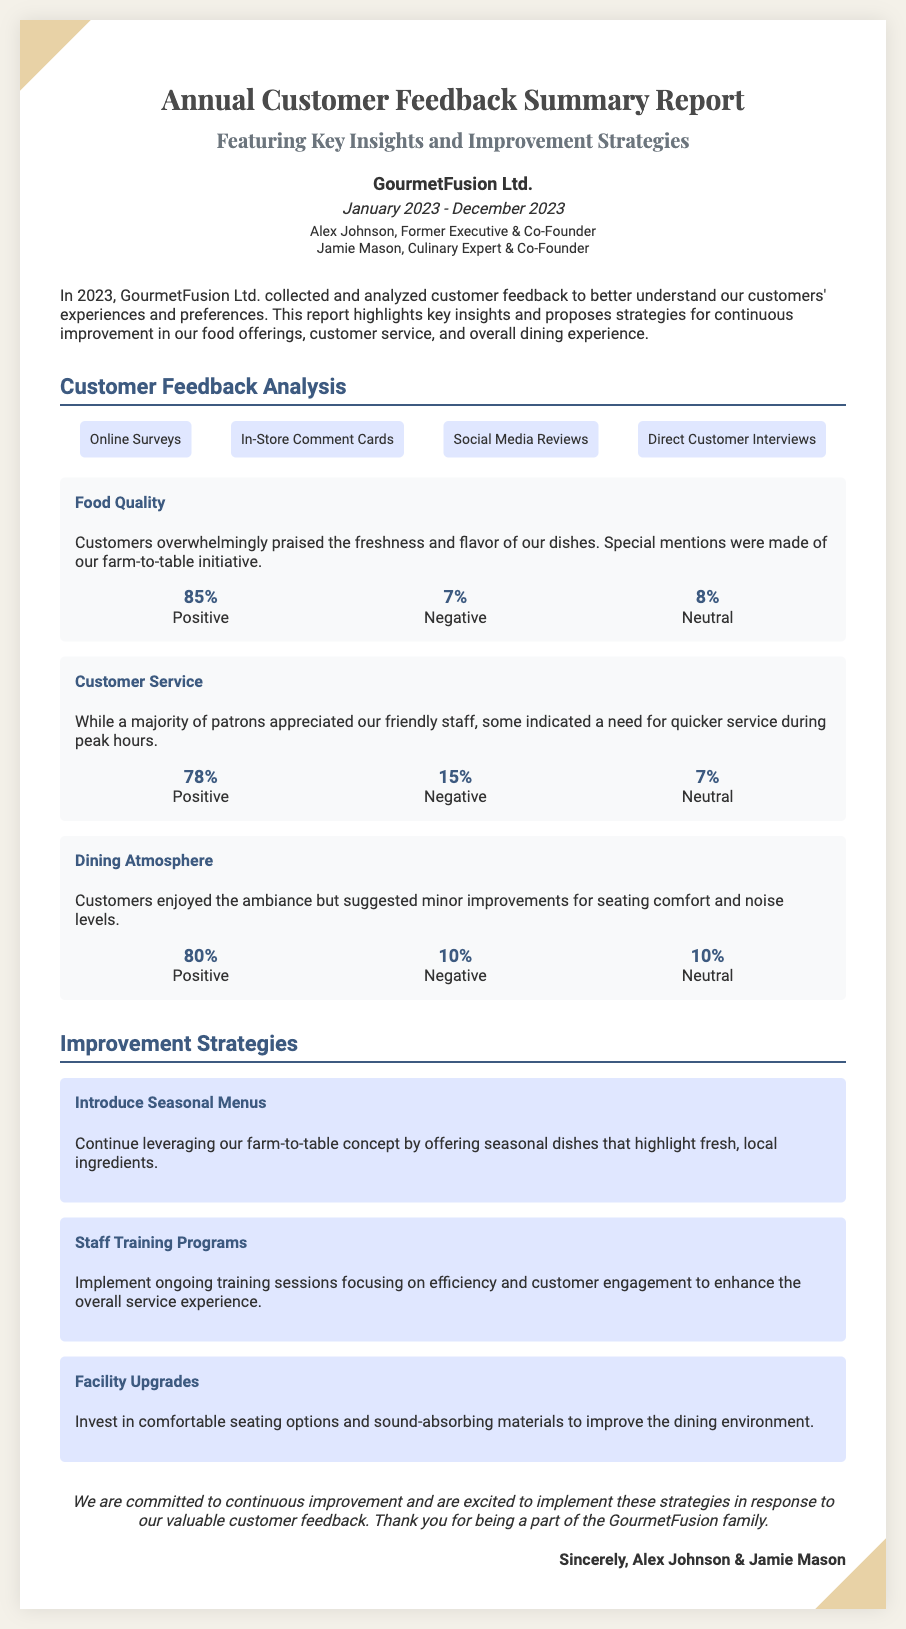What is the company name? The company name is presented prominently in the document's header.
Answer: GourmetFusion Ltd Who are the authors of the report? The authors are stated in the document, indicating who wrote the report.
Answer: Alex Johnson, Jamie Mason What percentage of customers rated the food quality positively? This information is found in the key insights section regarding food quality.
Answer: 85% What was a key suggestion for improvement in customer service? This detail can be found in the feedback analysis under customer service insights.
Answer: Quicker service What is the report period covered? The period of the report is mentioned in the header section.
Answer: January 2023 - December 2023 What is one proposed improvement strategy? Proposed strategies are listed in the report, focusing on enhancing customer experience.
Answer: Introduce Seasonal Menus How many negative responses were recorded for Dining Atmosphere? This percentage is detailed in the insights about dining atmosphere in the report.
Answer: 10% What is the positive feedback percentage for Customer Service? This statistic can be located in the summary of the customer service section.
Answer: 78% What type of feedback sources were used for this report? The report outlines various methods used to collect feedback from customers.
Answer: Online Surveys, In-Store Comment Cards, Social Media Reviews, Direct Customer Interviews 